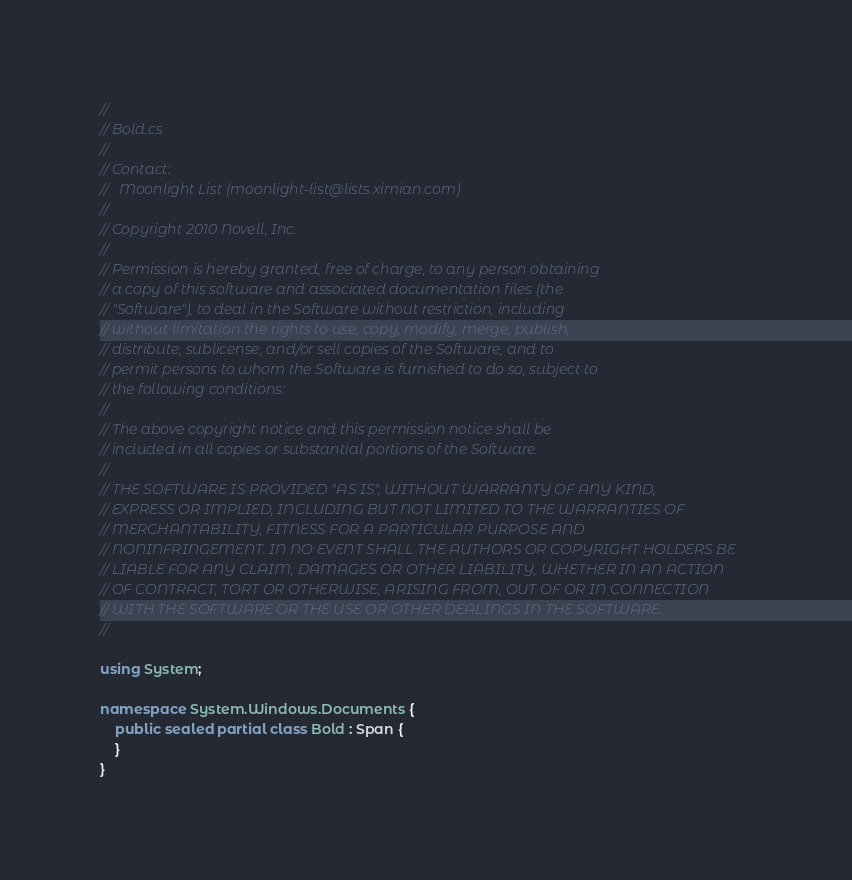Convert code to text. <code><loc_0><loc_0><loc_500><loc_500><_C#_>// 
// Bold.cs
// 
// Contact:
//   Moonlight List (moonlight-list@lists.ximian.com)
// 
// Copyright 2010 Novell, Inc.
// 
// Permission is hereby granted, free of charge, to any person obtaining
// a copy of this software and associated documentation files (the
// "Software"), to deal in the Software without restriction, including
// without limitation the rights to use, copy, modify, merge, publish,
// distribute, sublicense, and/or sell copies of the Software, and to
// permit persons to whom the Software is furnished to do so, subject to
// the following conditions:
// 
// The above copyright notice and this permission notice shall be
// included in all copies or substantial portions of the Software.
// 
// THE SOFTWARE IS PROVIDED "AS IS", WITHOUT WARRANTY OF ANY KIND,
// EXPRESS OR IMPLIED, INCLUDING BUT NOT LIMITED TO THE WARRANTIES OF
// MERCHANTABILITY, FITNESS FOR A PARTICULAR PURPOSE AND
// NONINFRINGEMENT. IN NO EVENT SHALL THE AUTHORS OR COPYRIGHT HOLDERS BE
// LIABLE FOR ANY CLAIM, DAMAGES OR OTHER LIABILITY, WHETHER IN AN ACTION
// OF CONTRACT, TORT OR OTHERWISE, ARISING FROM, OUT OF OR IN CONNECTION
// WITH THE SOFTWARE OR THE USE OR OTHER DEALINGS IN THE SOFTWARE.
// 

using System;

namespace System.Windows.Documents {
	public sealed partial class Bold : Span {
	}
}

</code> 